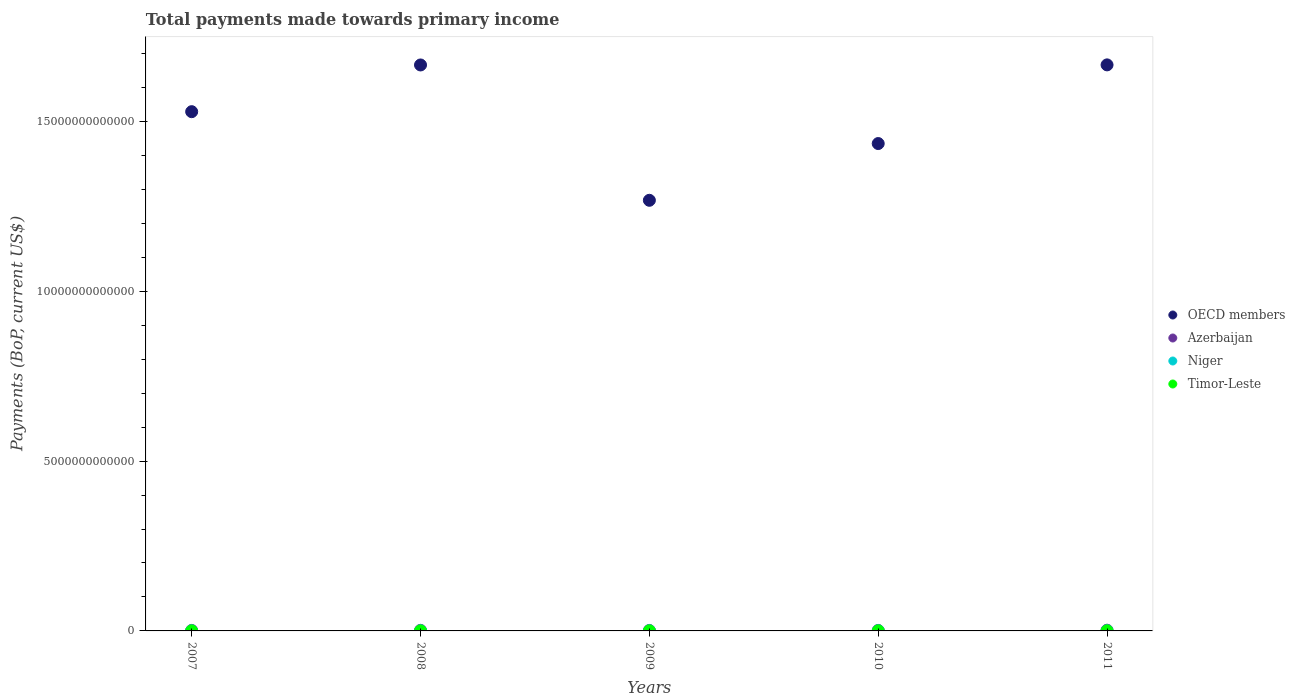Is the number of dotlines equal to the number of legend labels?
Provide a succinct answer. Yes. What is the total payments made towards primary income in Timor-Leste in 2010?
Provide a short and direct response. 1.35e+09. Across all years, what is the maximum total payments made towards primary income in OECD members?
Your answer should be compact. 1.67e+13. Across all years, what is the minimum total payments made towards primary income in Niger?
Give a very brief answer. 1.34e+09. In which year was the total payments made towards primary income in Timor-Leste minimum?
Ensure brevity in your answer.  2007. What is the total total payments made towards primary income in Azerbaijan in the graph?
Your answer should be compact. 8.16e+1. What is the difference between the total payments made towards primary income in Niger in 2008 and that in 2010?
Your answer should be very brief. -9.10e+08. What is the difference between the total payments made towards primary income in Azerbaijan in 2007 and the total payments made towards primary income in OECD members in 2008?
Your answer should be very brief. -1.66e+13. What is the average total payments made towards primary income in Niger per year?
Your answer should be very brief. 2.43e+09. In the year 2010, what is the difference between the total payments made towards primary income in Timor-Leste and total payments made towards primary income in OECD members?
Make the answer very short. -1.43e+13. In how many years, is the total payments made towards primary income in Niger greater than 12000000000000 US$?
Provide a short and direct response. 0. What is the ratio of the total payments made towards primary income in Azerbaijan in 2007 to that in 2008?
Your response must be concise. 0.86. Is the total payments made towards primary income in OECD members in 2007 less than that in 2011?
Offer a terse response. Yes. What is the difference between the highest and the second highest total payments made towards primary income in Azerbaijan?
Provide a succinct answer. 4.50e+09. What is the difference between the highest and the lowest total payments made towards primary income in Niger?
Your answer should be compact. 1.86e+09. In how many years, is the total payments made towards primary income in Niger greater than the average total payments made towards primary income in Niger taken over all years?
Keep it short and to the point. 3. How many years are there in the graph?
Your response must be concise. 5. What is the difference between two consecutive major ticks on the Y-axis?
Give a very brief answer. 5.00e+12. Does the graph contain any zero values?
Ensure brevity in your answer.  No. Does the graph contain grids?
Keep it short and to the point. No. Where does the legend appear in the graph?
Keep it short and to the point. Center right. What is the title of the graph?
Make the answer very short. Total payments made towards primary income. What is the label or title of the X-axis?
Provide a short and direct response. Years. What is the label or title of the Y-axis?
Give a very brief answer. Payments (BoP, current US$). What is the Payments (BoP, current US$) of OECD members in 2007?
Keep it short and to the point. 1.53e+13. What is the Payments (BoP, current US$) of Azerbaijan in 2007?
Make the answer very short. 1.47e+1. What is the Payments (BoP, current US$) of Niger in 2007?
Your answer should be compact. 1.34e+09. What is the Payments (BoP, current US$) in Timor-Leste in 2007?
Keep it short and to the point. 5.06e+08. What is the Payments (BoP, current US$) of OECD members in 2008?
Your answer should be compact. 1.67e+13. What is the Payments (BoP, current US$) in Azerbaijan in 2008?
Your answer should be very brief. 1.71e+1. What is the Payments (BoP, current US$) in Niger in 2008?
Provide a succinct answer. 2.01e+09. What is the Payments (BoP, current US$) in Timor-Leste in 2008?
Provide a succinct answer. 8.10e+08. What is the Payments (BoP, current US$) in OECD members in 2009?
Provide a succinct answer. 1.27e+13. What is the Payments (BoP, current US$) in Azerbaijan in 2009?
Offer a very short reply. 1.39e+1. What is the Payments (BoP, current US$) of Niger in 2009?
Your answer should be very brief. 2.66e+09. What is the Payments (BoP, current US$) of Timor-Leste in 2009?
Keep it short and to the point. 1.18e+09. What is the Payments (BoP, current US$) of OECD members in 2010?
Provide a short and direct response. 1.43e+13. What is the Payments (BoP, current US$) in Azerbaijan in 2010?
Offer a very short reply. 1.44e+1. What is the Payments (BoP, current US$) of Niger in 2010?
Keep it short and to the point. 2.92e+09. What is the Payments (BoP, current US$) of Timor-Leste in 2010?
Your answer should be very brief. 1.35e+09. What is the Payments (BoP, current US$) of OECD members in 2011?
Your answer should be compact. 1.67e+13. What is the Payments (BoP, current US$) of Azerbaijan in 2011?
Keep it short and to the point. 2.16e+1. What is the Payments (BoP, current US$) of Niger in 2011?
Offer a terse response. 3.21e+09. What is the Payments (BoP, current US$) of Timor-Leste in 2011?
Your response must be concise. 1.88e+09. Across all years, what is the maximum Payments (BoP, current US$) in OECD members?
Offer a very short reply. 1.67e+13. Across all years, what is the maximum Payments (BoP, current US$) of Azerbaijan?
Your answer should be very brief. 2.16e+1. Across all years, what is the maximum Payments (BoP, current US$) of Niger?
Your answer should be compact. 3.21e+09. Across all years, what is the maximum Payments (BoP, current US$) of Timor-Leste?
Your answer should be very brief. 1.88e+09. Across all years, what is the minimum Payments (BoP, current US$) in OECD members?
Offer a very short reply. 1.27e+13. Across all years, what is the minimum Payments (BoP, current US$) in Azerbaijan?
Ensure brevity in your answer.  1.39e+1. Across all years, what is the minimum Payments (BoP, current US$) of Niger?
Provide a short and direct response. 1.34e+09. Across all years, what is the minimum Payments (BoP, current US$) of Timor-Leste?
Provide a short and direct response. 5.06e+08. What is the total Payments (BoP, current US$) in OECD members in the graph?
Offer a very short reply. 7.56e+13. What is the total Payments (BoP, current US$) in Azerbaijan in the graph?
Your answer should be very brief. 8.16e+1. What is the total Payments (BoP, current US$) in Niger in the graph?
Your response must be concise. 1.21e+1. What is the total Payments (BoP, current US$) in Timor-Leste in the graph?
Your answer should be compact. 5.72e+09. What is the difference between the Payments (BoP, current US$) of OECD members in 2007 and that in 2008?
Ensure brevity in your answer.  -1.38e+12. What is the difference between the Payments (BoP, current US$) of Azerbaijan in 2007 and that in 2008?
Offer a terse response. -2.41e+09. What is the difference between the Payments (BoP, current US$) of Niger in 2007 and that in 2008?
Your response must be concise. -6.63e+08. What is the difference between the Payments (BoP, current US$) in Timor-Leste in 2007 and that in 2008?
Ensure brevity in your answer.  -3.03e+08. What is the difference between the Payments (BoP, current US$) of OECD members in 2007 and that in 2009?
Provide a succinct answer. 2.61e+12. What is the difference between the Payments (BoP, current US$) in Azerbaijan in 2007 and that in 2009?
Provide a short and direct response. 8.12e+08. What is the difference between the Payments (BoP, current US$) of Niger in 2007 and that in 2009?
Offer a very short reply. -1.31e+09. What is the difference between the Payments (BoP, current US$) of Timor-Leste in 2007 and that in 2009?
Your response must be concise. -6.74e+08. What is the difference between the Payments (BoP, current US$) in OECD members in 2007 and that in 2010?
Keep it short and to the point. 9.38e+11. What is the difference between the Payments (BoP, current US$) of Azerbaijan in 2007 and that in 2010?
Your answer should be compact. 2.90e+08. What is the difference between the Payments (BoP, current US$) of Niger in 2007 and that in 2010?
Make the answer very short. -1.57e+09. What is the difference between the Payments (BoP, current US$) in Timor-Leste in 2007 and that in 2010?
Make the answer very short. -8.45e+08. What is the difference between the Payments (BoP, current US$) of OECD members in 2007 and that in 2011?
Ensure brevity in your answer.  -1.38e+12. What is the difference between the Payments (BoP, current US$) in Azerbaijan in 2007 and that in 2011?
Your answer should be compact. -6.92e+09. What is the difference between the Payments (BoP, current US$) in Niger in 2007 and that in 2011?
Keep it short and to the point. -1.86e+09. What is the difference between the Payments (BoP, current US$) in Timor-Leste in 2007 and that in 2011?
Keep it short and to the point. -1.37e+09. What is the difference between the Payments (BoP, current US$) of OECD members in 2008 and that in 2009?
Offer a terse response. 3.98e+12. What is the difference between the Payments (BoP, current US$) in Azerbaijan in 2008 and that in 2009?
Offer a terse response. 3.22e+09. What is the difference between the Payments (BoP, current US$) of Niger in 2008 and that in 2009?
Your answer should be compact. -6.50e+08. What is the difference between the Payments (BoP, current US$) of Timor-Leste in 2008 and that in 2009?
Keep it short and to the point. -3.70e+08. What is the difference between the Payments (BoP, current US$) in OECD members in 2008 and that in 2010?
Keep it short and to the point. 2.31e+12. What is the difference between the Payments (BoP, current US$) in Azerbaijan in 2008 and that in 2010?
Your response must be concise. 2.70e+09. What is the difference between the Payments (BoP, current US$) of Niger in 2008 and that in 2010?
Keep it short and to the point. -9.10e+08. What is the difference between the Payments (BoP, current US$) of Timor-Leste in 2008 and that in 2010?
Give a very brief answer. -5.41e+08. What is the difference between the Payments (BoP, current US$) of OECD members in 2008 and that in 2011?
Your answer should be compact. -2.55e+09. What is the difference between the Payments (BoP, current US$) in Azerbaijan in 2008 and that in 2011?
Your answer should be very brief. -4.50e+09. What is the difference between the Payments (BoP, current US$) of Niger in 2008 and that in 2011?
Give a very brief answer. -1.20e+09. What is the difference between the Payments (BoP, current US$) in Timor-Leste in 2008 and that in 2011?
Ensure brevity in your answer.  -1.07e+09. What is the difference between the Payments (BoP, current US$) in OECD members in 2009 and that in 2010?
Give a very brief answer. -1.67e+12. What is the difference between the Payments (BoP, current US$) of Azerbaijan in 2009 and that in 2010?
Make the answer very short. -5.22e+08. What is the difference between the Payments (BoP, current US$) of Niger in 2009 and that in 2010?
Offer a terse response. -2.59e+08. What is the difference between the Payments (BoP, current US$) in Timor-Leste in 2009 and that in 2010?
Make the answer very short. -1.71e+08. What is the difference between the Payments (BoP, current US$) of OECD members in 2009 and that in 2011?
Your answer should be compact. -3.99e+12. What is the difference between the Payments (BoP, current US$) in Azerbaijan in 2009 and that in 2011?
Give a very brief answer. -7.73e+09. What is the difference between the Payments (BoP, current US$) of Niger in 2009 and that in 2011?
Provide a short and direct response. -5.50e+08. What is the difference between the Payments (BoP, current US$) of Timor-Leste in 2009 and that in 2011?
Ensure brevity in your answer.  -6.95e+08. What is the difference between the Payments (BoP, current US$) of OECD members in 2010 and that in 2011?
Offer a terse response. -2.32e+12. What is the difference between the Payments (BoP, current US$) in Azerbaijan in 2010 and that in 2011?
Provide a succinct answer. -7.21e+09. What is the difference between the Payments (BoP, current US$) of Niger in 2010 and that in 2011?
Your answer should be compact. -2.90e+08. What is the difference between the Payments (BoP, current US$) in Timor-Leste in 2010 and that in 2011?
Your answer should be very brief. -5.24e+08. What is the difference between the Payments (BoP, current US$) of OECD members in 2007 and the Payments (BoP, current US$) of Azerbaijan in 2008?
Your response must be concise. 1.53e+13. What is the difference between the Payments (BoP, current US$) in OECD members in 2007 and the Payments (BoP, current US$) in Niger in 2008?
Offer a very short reply. 1.53e+13. What is the difference between the Payments (BoP, current US$) in OECD members in 2007 and the Payments (BoP, current US$) in Timor-Leste in 2008?
Provide a succinct answer. 1.53e+13. What is the difference between the Payments (BoP, current US$) in Azerbaijan in 2007 and the Payments (BoP, current US$) in Niger in 2008?
Your answer should be compact. 1.27e+1. What is the difference between the Payments (BoP, current US$) of Azerbaijan in 2007 and the Payments (BoP, current US$) of Timor-Leste in 2008?
Provide a short and direct response. 1.39e+1. What is the difference between the Payments (BoP, current US$) of Niger in 2007 and the Payments (BoP, current US$) of Timor-Leste in 2008?
Ensure brevity in your answer.  5.33e+08. What is the difference between the Payments (BoP, current US$) in OECD members in 2007 and the Payments (BoP, current US$) in Azerbaijan in 2009?
Your response must be concise. 1.53e+13. What is the difference between the Payments (BoP, current US$) in OECD members in 2007 and the Payments (BoP, current US$) in Niger in 2009?
Your answer should be very brief. 1.53e+13. What is the difference between the Payments (BoP, current US$) of OECD members in 2007 and the Payments (BoP, current US$) of Timor-Leste in 2009?
Your answer should be compact. 1.53e+13. What is the difference between the Payments (BoP, current US$) of Azerbaijan in 2007 and the Payments (BoP, current US$) of Niger in 2009?
Your response must be concise. 1.20e+1. What is the difference between the Payments (BoP, current US$) of Azerbaijan in 2007 and the Payments (BoP, current US$) of Timor-Leste in 2009?
Provide a short and direct response. 1.35e+1. What is the difference between the Payments (BoP, current US$) in Niger in 2007 and the Payments (BoP, current US$) in Timor-Leste in 2009?
Ensure brevity in your answer.  1.63e+08. What is the difference between the Payments (BoP, current US$) of OECD members in 2007 and the Payments (BoP, current US$) of Azerbaijan in 2010?
Offer a very short reply. 1.53e+13. What is the difference between the Payments (BoP, current US$) in OECD members in 2007 and the Payments (BoP, current US$) in Niger in 2010?
Your answer should be very brief. 1.53e+13. What is the difference between the Payments (BoP, current US$) in OECD members in 2007 and the Payments (BoP, current US$) in Timor-Leste in 2010?
Your response must be concise. 1.53e+13. What is the difference between the Payments (BoP, current US$) in Azerbaijan in 2007 and the Payments (BoP, current US$) in Niger in 2010?
Ensure brevity in your answer.  1.18e+1. What is the difference between the Payments (BoP, current US$) in Azerbaijan in 2007 and the Payments (BoP, current US$) in Timor-Leste in 2010?
Provide a short and direct response. 1.33e+1. What is the difference between the Payments (BoP, current US$) of Niger in 2007 and the Payments (BoP, current US$) of Timor-Leste in 2010?
Keep it short and to the point. -8.14e+06. What is the difference between the Payments (BoP, current US$) in OECD members in 2007 and the Payments (BoP, current US$) in Azerbaijan in 2011?
Provide a succinct answer. 1.53e+13. What is the difference between the Payments (BoP, current US$) in OECD members in 2007 and the Payments (BoP, current US$) in Niger in 2011?
Your response must be concise. 1.53e+13. What is the difference between the Payments (BoP, current US$) in OECD members in 2007 and the Payments (BoP, current US$) in Timor-Leste in 2011?
Ensure brevity in your answer.  1.53e+13. What is the difference between the Payments (BoP, current US$) of Azerbaijan in 2007 and the Payments (BoP, current US$) of Niger in 2011?
Make the answer very short. 1.15e+1. What is the difference between the Payments (BoP, current US$) in Azerbaijan in 2007 and the Payments (BoP, current US$) in Timor-Leste in 2011?
Your answer should be compact. 1.28e+1. What is the difference between the Payments (BoP, current US$) in Niger in 2007 and the Payments (BoP, current US$) in Timor-Leste in 2011?
Offer a very short reply. -5.32e+08. What is the difference between the Payments (BoP, current US$) in OECD members in 2008 and the Payments (BoP, current US$) in Azerbaijan in 2009?
Offer a terse response. 1.66e+13. What is the difference between the Payments (BoP, current US$) of OECD members in 2008 and the Payments (BoP, current US$) of Niger in 2009?
Your answer should be very brief. 1.67e+13. What is the difference between the Payments (BoP, current US$) of OECD members in 2008 and the Payments (BoP, current US$) of Timor-Leste in 2009?
Your response must be concise. 1.67e+13. What is the difference between the Payments (BoP, current US$) of Azerbaijan in 2008 and the Payments (BoP, current US$) of Niger in 2009?
Offer a very short reply. 1.44e+1. What is the difference between the Payments (BoP, current US$) of Azerbaijan in 2008 and the Payments (BoP, current US$) of Timor-Leste in 2009?
Ensure brevity in your answer.  1.59e+1. What is the difference between the Payments (BoP, current US$) of Niger in 2008 and the Payments (BoP, current US$) of Timor-Leste in 2009?
Offer a very short reply. 8.26e+08. What is the difference between the Payments (BoP, current US$) of OECD members in 2008 and the Payments (BoP, current US$) of Azerbaijan in 2010?
Keep it short and to the point. 1.66e+13. What is the difference between the Payments (BoP, current US$) in OECD members in 2008 and the Payments (BoP, current US$) in Niger in 2010?
Your answer should be compact. 1.67e+13. What is the difference between the Payments (BoP, current US$) of OECD members in 2008 and the Payments (BoP, current US$) of Timor-Leste in 2010?
Your response must be concise. 1.67e+13. What is the difference between the Payments (BoP, current US$) of Azerbaijan in 2008 and the Payments (BoP, current US$) of Niger in 2010?
Offer a very short reply. 1.42e+1. What is the difference between the Payments (BoP, current US$) of Azerbaijan in 2008 and the Payments (BoP, current US$) of Timor-Leste in 2010?
Ensure brevity in your answer.  1.57e+1. What is the difference between the Payments (BoP, current US$) in Niger in 2008 and the Payments (BoP, current US$) in Timor-Leste in 2010?
Your response must be concise. 6.55e+08. What is the difference between the Payments (BoP, current US$) of OECD members in 2008 and the Payments (BoP, current US$) of Azerbaijan in 2011?
Provide a short and direct response. 1.66e+13. What is the difference between the Payments (BoP, current US$) in OECD members in 2008 and the Payments (BoP, current US$) in Niger in 2011?
Ensure brevity in your answer.  1.67e+13. What is the difference between the Payments (BoP, current US$) in OECD members in 2008 and the Payments (BoP, current US$) in Timor-Leste in 2011?
Ensure brevity in your answer.  1.67e+13. What is the difference between the Payments (BoP, current US$) in Azerbaijan in 2008 and the Payments (BoP, current US$) in Niger in 2011?
Provide a succinct answer. 1.39e+1. What is the difference between the Payments (BoP, current US$) in Azerbaijan in 2008 and the Payments (BoP, current US$) in Timor-Leste in 2011?
Ensure brevity in your answer.  1.52e+1. What is the difference between the Payments (BoP, current US$) of Niger in 2008 and the Payments (BoP, current US$) of Timor-Leste in 2011?
Provide a succinct answer. 1.31e+08. What is the difference between the Payments (BoP, current US$) of OECD members in 2009 and the Payments (BoP, current US$) of Azerbaijan in 2010?
Offer a terse response. 1.27e+13. What is the difference between the Payments (BoP, current US$) in OECD members in 2009 and the Payments (BoP, current US$) in Niger in 2010?
Your answer should be compact. 1.27e+13. What is the difference between the Payments (BoP, current US$) in OECD members in 2009 and the Payments (BoP, current US$) in Timor-Leste in 2010?
Offer a very short reply. 1.27e+13. What is the difference between the Payments (BoP, current US$) in Azerbaijan in 2009 and the Payments (BoP, current US$) in Niger in 2010?
Keep it short and to the point. 1.09e+1. What is the difference between the Payments (BoP, current US$) in Azerbaijan in 2009 and the Payments (BoP, current US$) in Timor-Leste in 2010?
Provide a short and direct response. 1.25e+1. What is the difference between the Payments (BoP, current US$) in Niger in 2009 and the Payments (BoP, current US$) in Timor-Leste in 2010?
Make the answer very short. 1.31e+09. What is the difference between the Payments (BoP, current US$) in OECD members in 2009 and the Payments (BoP, current US$) in Azerbaijan in 2011?
Offer a very short reply. 1.27e+13. What is the difference between the Payments (BoP, current US$) of OECD members in 2009 and the Payments (BoP, current US$) of Niger in 2011?
Your answer should be compact. 1.27e+13. What is the difference between the Payments (BoP, current US$) in OECD members in 2009 and the Payments (BoP, current US$) in Timor-Leste in 2011?
Your answer should be very brief. 1.27e+13. What is the difference between the Payments (BoP, current US$) in Azerbaijan in 2009 and the Payments (BoP, current US$) in Niger in 2011?
Give a very brief answer. 1.07e+1. What is the difference between the Payments (BoP, current US$) of Azerbaijan in 2009 and the Payments (BoP, current US$) of Timor-Leste in 2011?
Keep it short and to the point. 1.20e+1. What is the difference between the Payments (BoP, current US$) of Niger in 2009 and the Payments (BoP, current US$) of Timor-Leste in 2011?
Ensure brevity in your answer.  7.82e+08. What is the difference between the Payments (BoP, current US$) of OECD members in 2010 and the Payments (BoP, current US$) of Azerbaijan in 2011?
Provide a short and direct response. 1.43e+13. What is the difference between the Payments (BoP, current US$) in OECD members in 2010 and the Payments (BoP, current US$) in Niger in 2011?
Ensure brevity in your answer.  1.43e+13. What is the difference between the Payments (BoP, current US$) of OECD members in 2010 and the Payments (BoP, current US$) of Timor-Leste in 2011?
Make the answer very short. 1.43e+13. What is the difference between the Payments (BoP, current US$) of Azerbaijan in 2010 and the Payments (BoP, current US$) of Niger in 2011?
Your answer should be compact. 1.12e+1. What is the difference between the Payments (BoP, current US$) in Azerbaijan in 2010 and the Payments (BoP, current US$) in Timor-Leste in 2011?
Make the answer very short. 1.25e+1. What is the difference between the Payments (BoP, current US$) of Niger in 2010 and the Payments (BoP, current US$) of Timor-Leste in 2011?
Offer a terse response. 1.04e+09. What is the average Payments (BoP, current US$) in OECD members per year?
Ensure brevity in your answer.  1.51e+13. What is the average Payments (BoP, current US$) of Azerbaijan per year?
Your response must be concise. 1.63e+1. What is the average Payments (BoP, current US$) in Niger per year?
Give a very brief answer. 2.43e+09. What is the average Payments (BoP, current US$) in Timor-Leste per year?
Provide a short and direct response. 1.14e+09. In the year 2007, what is the difference between the Payments (BoP, current US$) of OECD members and Payments (BoP, current US$) of Azerbaijan?
Ensure brevity in your answer.  1.53e+13. In the year 2007, what is the difference between the Payments (BoP, current US$) of OECD members and Payments (BoP, current US$) of Niger?
Ensure brevity in your answer.  1.53e+13. In the year 2007, what is the difference between the Payments (BoP, current US$) of OECD members and Payments (BoP, current US$) of Timor-Leste?
Provide a short and direct response. 1.53e+13. In the year 2007, what is the difference between the Payments (BoP, current US$) in Azerbaijan and Payments (BoP, current US$) in Niger?
Make the answer very short. 1.33e+1. In the year 2007, what is the difference between the Payments (BoP, current US$) in Azerbaijan and Payments (BoP, current US$) in Timor-Leste?
Your answer should be compact. 1.42e+1. In the year 2007, what is the difference between the Payments (BoP, current US$) of Niger and Payments (BoP, current US$) of Timor-Leste?
Ensure brevity in your answer.  8.37e+08. In the year 2008, what is the difference between the Payments (BoP, current US$) in OECD members and Payments (BoP, current US$) in Azerbaijan?
Offer a terse response. 1.66e+13. In the year 2008, what is the difference between the Payments (BoP, current US$) in OECD members and Payments (BoP, current US$) in Niger?
Offer a very short reply. 1.67e+13. In the year 2008, what is the difference between the Payments (BoP, current US$) of OECD members and Payments (BoP, current US$) of Timor-Leste?
Make the answer very short. 1.67e+13. In the year 2008, what is the difference between the Payments (BoP, current US$) in Azerbaijan and Payments (BoP, current US$) in Niger?
Keep it short and to the point. 1.51e+1. In the year 2008, what is the difference between the Payments (BoP, current US$) in Azerbaijan and Payments (BoP, current US$) in Timor-Leste?
Make the answer very short. 1.63e+1. In the year 2008, what is the difference between the Payments (BoP, current US$) of Niger and Payments (BoP, current US$) of Timor-Leste?
Provide a short and direct response. 1.20e+09. In the year 2009, what is the difference between the Payments (BoP, current US$) in OECD members and Payments (BoP, current US$) in Azerbaijan?
Ensure brevity in your answer.  1.27e+13. In the year 2009, what is the difference between the Payments (BoP, current US$) of OECD members and Payments (BoP, current US$) of Niger?
Provide a short and direct response. 1.27e+13. In the year 2009, what is the difference between the Payments (BoP, current US$) in OECD members and Payments (BoP, current US$) in Timor-Leste?
Keep it short and to the point. 1.27e+13. In the year 2009, what is the difference between the Payments (BoP, current US$) of Azerbaijan and Payments (BoP, current US$) of Niger?
Ensure brevity in your answer.  1.12e+1. In the year 2009, what is the difference between the Payments (BoP, current US$) of Azerbaijan and Payments (BoP, current US$) of Timor-Leste?
Offer a terse response. 1.27e+1. In the year 2009, what is the difference between the Payments (BoP, current US$) of Niger and Payments (BoP, current US$) of Timor-Leste?
Offer a very short reply. 1.48e+09. In the year 2010, what is the difference between the Payments (BoP, current US$) of OECD members and Payments (BoP, current US$) of Azerbaijan?
Offer a terse response. 1.43e+13. In the year 2010, what is the difference between the Payments (BoP, current US$) in OECD members and Payments (BoP, current US$) in Niger?
Your answer should be compact. 1.43e+13. In the year 2010, what is the difference between the Payments (BoP, current US$) of OECD members and Payments (BoP, current US$) of Timor-Leste?
Provide a succinct answer. 1.43e+13. In the year 2010, what is the difference between the Payments (BoP, current US$) of Azerbaijan and Payments (BoP, current US$) of Niger?
Keep it short and to the point. 1.15e+1. In the year 2010, what is the difference between the Payments (BoP, current US$) in Azerbaijan and Payments (BoP, current US$) in Timor-Leste?
Your response must be concise. 1.30e+1. In the year 2010, what is the difference between the Payments (BoP, current US$) in Niger and Payments (BoP, current US$) in Timor-Leste?
Offer a terse response. 1.57e+09. In the year 2011, what is the difference between the Payments (BoP, current US$) in OECD members and Payments (BoP, current US$) in Azerbaijan?
Provide a succinct answer. 1.66e+13. In the year 2011, what is the difference between the Payments (BoP, current US$) of OECD members and Payments (BoP, current US$) of Niger?
Provide a succinct answer. 1.67e+13. In the year 2011, what is the difference between the Payments (BoP, current US$) in OECD members and Payments (BoP, current US$) in Timor-Leste?
Offer a terse response. 1.67e+13. In the year 2011, what is the difference between the Payments (BoP, current US$) of Azerbaijan and Payments (BoP, current US$) of Niger?
Offer a very short reply. 1.84e+1. In the year 2011, what is the difference between the Payments (BoP, current US$) of Azerbaijan and Payments (BoP, current US$) of Timor-Leste?
Make the answer very short. 1.97e+1. In the year 2011, what is the difference between the Payments (BoP, current US$) of Niger and Payments (BoP, current US$) of Timor-Leste?
Your answer should be very brief. 1.33e+09. What is the ratio of the Payments (BoP, current US$) of OECD members in 2007 to that in 2008?
Your response must be concise. 0.92. What is the ratio of the Payments (BoP, current US$) of Azerbaijan in 2007 to that in 2008?
Your response must be concise. 0.86. What is the ratio of the Payments (BoP, current US$) of Niger in 2007 to that in 2008?
Provide a short and direct response. 0.67. What is the ratio of the Payments (BoP, current US$) of Timor-Leste in 2007 to that in 2008?
Offer a very short reply. 0.63. What is the ratio of the Payments (BoP, current US$) in OECD members in 2007 to that in 2009?
Ensure brevity in your answer.  1.21. What is the ratio of the Payments (BoP, current US$) in Azerbaijan in 2007 to that in 2009?
Provide a succinct answer. 1.06. What is the ratio of the Payments (BoP, current US$) of Niger in 2007 to that in 2009?
Give a very brief answer. 0.51. What is the ratio of the Payments (BoP, current US$) of Timor-Leste in 2007 to that in 2009?
Your answer should be compact. 0.43. What is the ratio of the Payments (BoP, current US$) in OECD members in 2007 to that in 2010?
Ensure brevity in your answer.  1.07. What is the ratio of the Payments (BoP, current US$) in Azerbaijan in 2007 to that in 2010?
Offer a very short reply. 1.02. What is the ratio of the Payments (BoP, current US$) in Niger in 2007 to that in 2010?
Provide a short and direct response. 0.46. What is the ratio of the Payments (BoP, current US$) in Timor-Leste in 2007 to that in 2010?
Offer a terse response. 0.37. What is the ratio of the Payments (BoP, current US$) in OECD members in 2007 to that in 2011?
Provide a short and direct response. 0.92. What is the ratio of the Payments (BoP, current US$) of Azerbaijan in 2007 to that in 2011?
Provide a short and direct response. 0.68. What is the ratio of the Payments (BoP, current US$) in Niger in 2007 to that in 2011?
Make the answer very short. 0.42. What is the ratio of the Payments (BoP, current US$) of Timor-Leste in 2007 to that in 2011?
Keep it short and to the point. 0.27. What is the ratio of the Payments (BoP, current US$) in OECD members in 2008 to that in 2009?
Provide a short and direct response. 1.31. What is the ratio of the Payments (BoP, current US$) of Azerbaijan in 2008 to that in 2009?
Offer a terse response. 1.23. What is the ratio of the Payments (BoP, current US$) of Niger in 2008 to that in 2009?
Give a very brief answer. 0.76. What is the ratio of the Payments (BoP, current US$) in Timor-Leste in 2008 to that in 2009?
Offer a terse response. 0.69. What is the ratio of the Payments (BoP, current US$) of OECD members in 2008 to that in 2010?
Your response must be concise. 1.16. What is the ratio of the Payments (BoP, current US$) in Azerbaijan in 2008 to that in 2010?
Give a very brief answer. 1.19. What is the ratio of the Payments (BoP, current US$) of Niger in 2008 to that in 2010?
Make the answer very short. 0.69. What is the ratio of the Payments (BoP, current US$) in Timor-Leste in 2008 to that in 2010?
Ensure brevity in your answer.  0.6. What is the ratio of the Payments (BoP, current US$) of Azerbaijan in 2008 to that in 2011?
Make the answer very short. 0.79. What is the ratio of the Payments (BoP, current US$) in Niger in 2008 to that in 2011?
Ensure brevity in your answer.  0.63. What is the ratio of the Payments (BoP, current US$) of Timor-Leste in 2008 to that in 2011?
Offer a very short reply. 0.43. What is the ratio of the Payments (BoP, current US$) of OECD members in 2009 to that in 2010?
Offer a terse response. 0.88. What is the ratio of the Payments (BoP, current US$) in Azerbaijan in 2009 to that in 2010?
Offer a very short reply. 0.96. What is the ratio of the Payments (BoP, current US$) in Niger in 2009 to that in 2010?
Offer a terse response. 0.91. What is the ratio of the Payments (BoP, current US$) in Timor-Leste in 2009 to that in 2010?
Offer a very short reply. 0.87. What is the ratio of the Payments (BoP, current US$) in OECD members in 2009 to that in 2011?
Make the answer very short. 0.76. What is the ratio of the Payments (BoP, current US$) in Azerbaijan in 2009 to that in 2011?
Offer a terse response. 0.64. What is the ratio of the Payments (BoP, current US$) in Niger in 2009 to that in 2011?
Your answer should be very brief. 0.83. What is the ratio of the Payments (BoP, current US$) of Timor-Leste in 2009 to that in 2011?
Offer a terse response. 0.63. What is the ratio of the Payments (BoP, current US$) in OECD members in 2010 to that in 2011?
Give a very brief answer. 0.86. What is the ratio of the Payments (BoP, current US$) in Azerbaijan in 2010 to that in 2011?
Your answer should be very brief. 0.67. What is the ratio of the Payments (BoP, current US$) of Niger in 2010 to that in 2011?
Give a very brief answer. 0.91. What is the ratio of the Payments (BoP, current US$) in Timor-Leste in 2010 to that in 2011?
Provide a short and direct response. 0.72. What is the difference between the highest and the second highest Payments (BoP, current US$) of OECD members?
Your response must be concise. 2.55e+09. What is the difference between the highest and the second highest Payments (BoP, current US$) in Azerbaijan?
Give a very brief answer. 4.50e+09. What is the difference between the highest and the second highest Payments (BoP, current US$) in Niger?
Provide a succinct answer. 2.90e+08. What is the difference between the highest and the second highest Payments (BoP, current US$) of Timor-Leste?
Offer a very short reply. 5.24e+08. What is the difference between the highest and the lowest Payments (BoP, current US$) of OECD members?
Your answer should be very brief. 3.99e+12. What is the difference between the highest and the lowest Payments (BoP, current US$) of Azerbaijan?
Give a very brief answer. 7.73e+09. What is the difference between the highest and the lowest Payments (BoP, current US$) in Niger?
Keep it short and to the point. 1.86e+09. What is the difference between the highest and the lowest Payments (BoP, current US$) in Timor-Leste?
Offer a very short reply. 1.37e+09. 